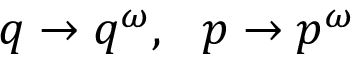<formula> <loc_0><loc_0><loc_500><loc_500>q \rightarrow q ^ { \omega } , \ \ p \rightarrow p ^ { \omega }</formula> 